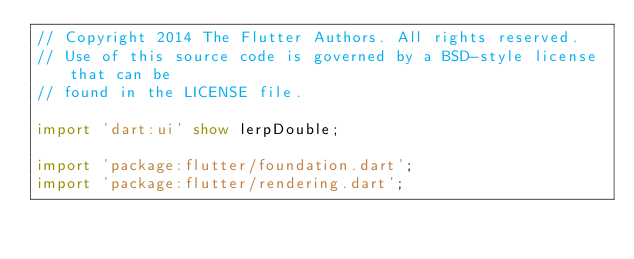<code> <loc_0><loc_0><loc_500><loc_500><_Dart_>// Copyright 2014 The Flutter Authors. All rights reserved.
// Use of this source code is governed by a BSD-style license that can be
// found in the LICENSE file.

import 'dart:ui' show lerpDouble;

import 'package:flutter/foundation.dart';
import 'package:flutter/rendering.dart';
</code> 